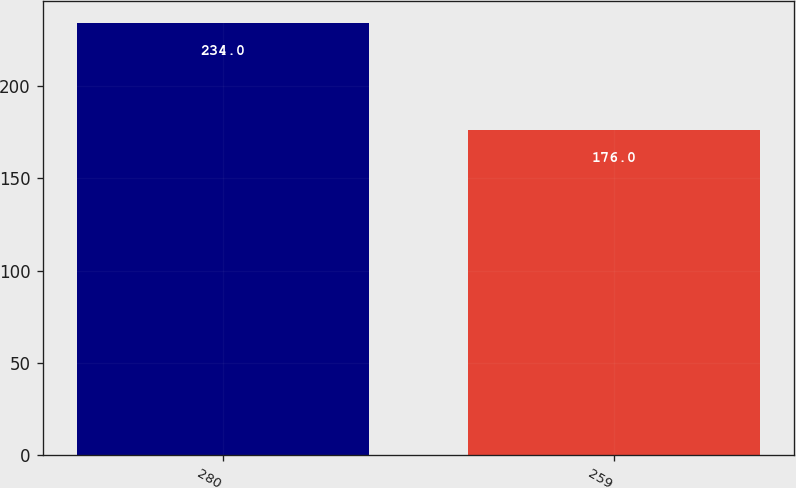<chart> <loc_0><loc_0><loc_500><loc_500><bar_chart><fcel>280<fcel>259<nl><fcel>234<fcel>176<nl></chart> 